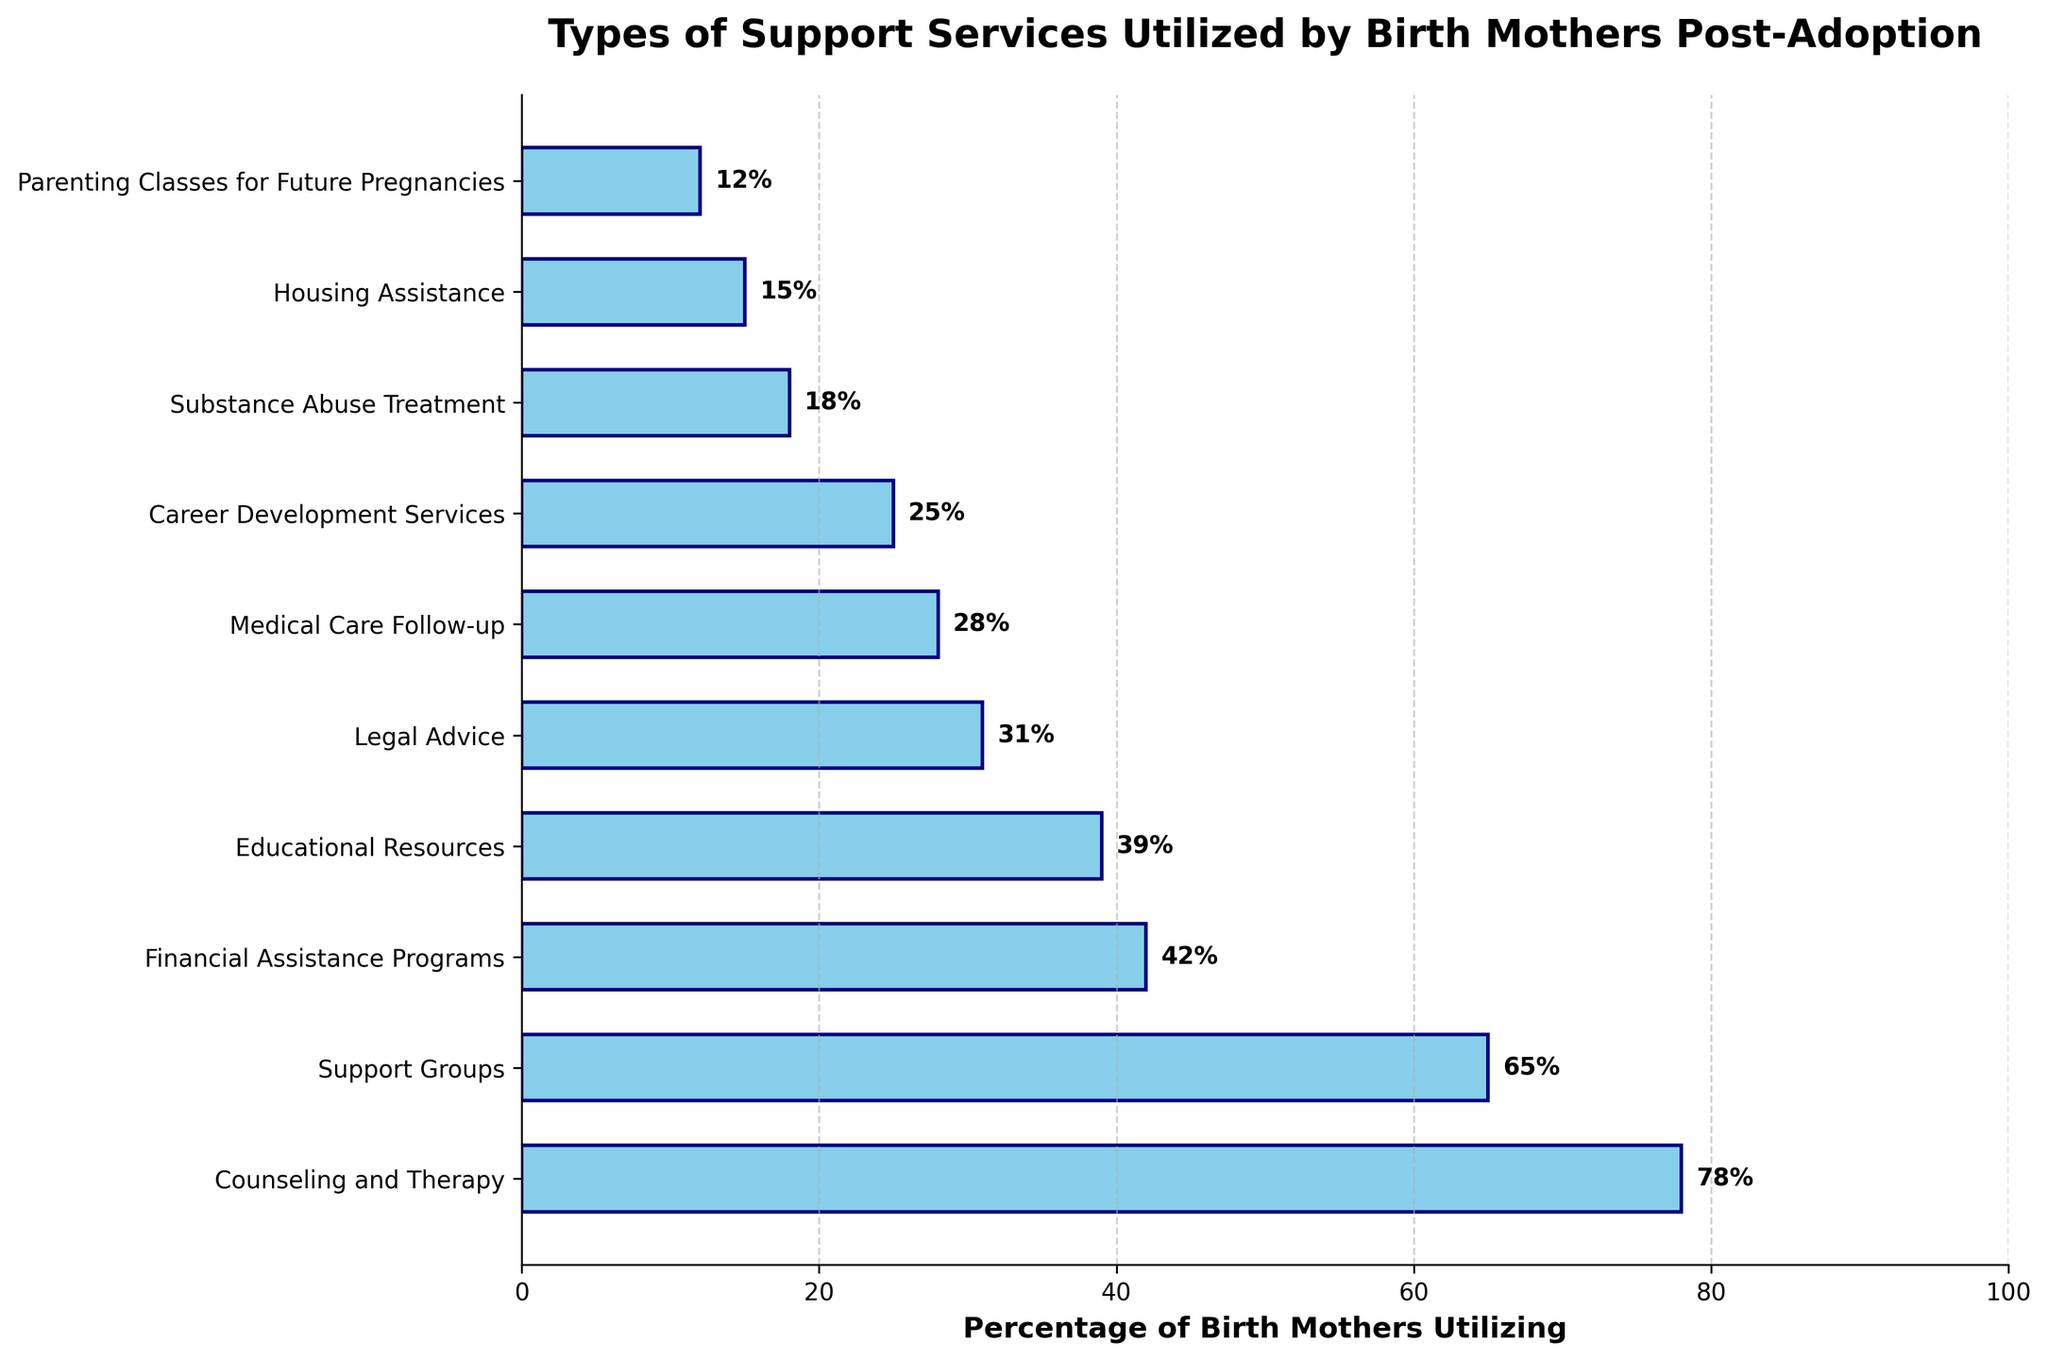What percentage of birth mothers utilize Counseling and Therapy services? The bar for Counseling and Therapy shows a percentage label at the end of the bar.
Answer: 78% How many types of support services are utilized by more than 50% of birth mothers? Identify bars with percentages higher than 50%. Counseling and Therapy (78%) and Support Groups (65%) are the only ones.
Answer: 2 Which support service has the lowest percentage of utilization? The bar with the smallest percentage shown is Parenting Classes for Future Pregnancies.
Answer: Parenting Classes for Future Pregnancies What is the combined percentage of birth mothers utilizing Financial Assistance Programs and Career Development Services? Add the percentages for Financial Assistance Programs (42%) and Career Development Services (25%). 42 + 25 = 67
Answer: 67% Which two support services have almost equal utilization percentages and how much off are they from each other? Compare the percentages and find similar values: Educational Resources (39%) and Financial Assistance Programs (42%). Difference is
Answer: 3% Is the percentage of birth mothers utilizing Legal Advice higher or lower than those utilizing Medical Care Follow-up? Compare the percentages of Legal Advice (31%) and Medical Care Follow-up (28%). Legal Advice is higher than Medical Care Follow-up.
Answer: Higher What is the average percentage of utilization for Counseling and Therapy, Support Groups, and Substance Abuse Treatment? (78% + 65% + 18%) / 3 = 161 / 3 = 53.67
Answer: 53.67% Which support services have a utilization percentage below 20%? Identify bars with percentages less than 20%: Substance Abuse Treatment (18%) and Housing Assistance (15%) and Parenting Classes for Future Pregnancies (12%).
Answer: 3 Is the utilization of Housing Assistance higher, lower, or equal to one-fifth of Counseling and Therapy’s utilization? Counseling and Therapy is at 78%, one-fifth of which is 78 / 5 = 15.6. Housing Assistance is 15%, so it is lower.
Answer: Lower What is the difference in utilization percentages between the most utilized support service and the least utilized support service? The most utilized is Counseling and Therapy (78%) and the least is Parenting Classes for Future Pregnancies (12%). Difference is 78 - 12 = 66.
Answer: 66 